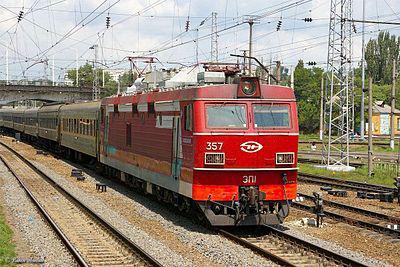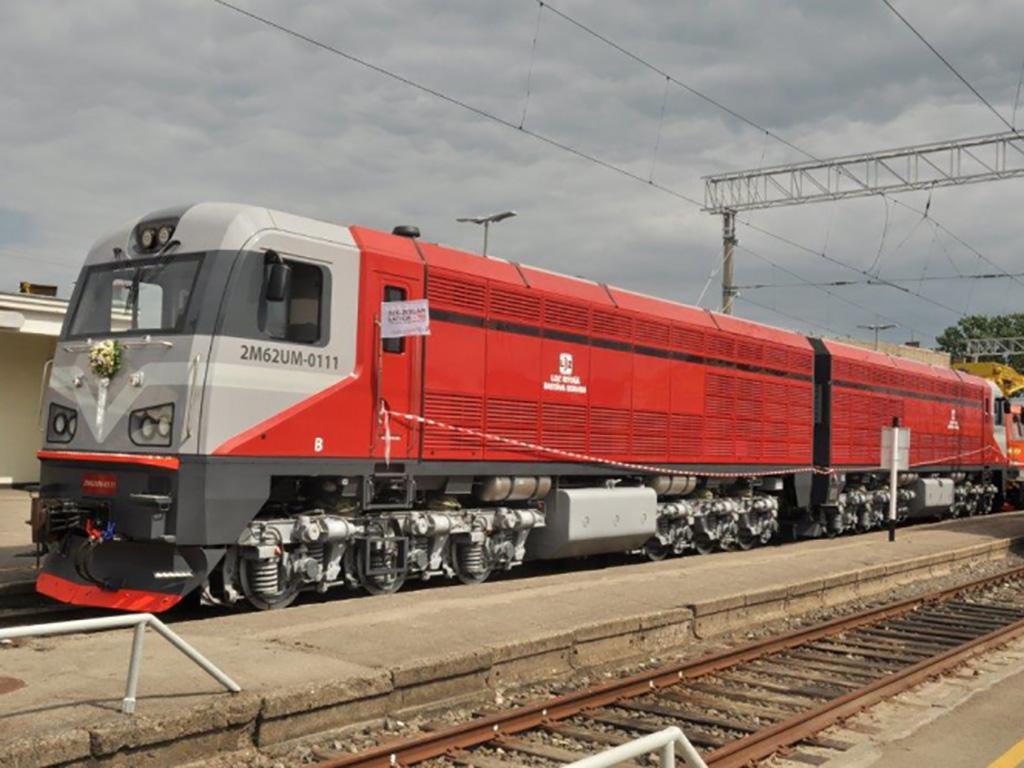The first image is the image on the left, the second image is the image on the right. Analyze the images presented: Is the assertion "All trains are angled forward in the same direction." valid? Answer yes or no. No. The first image is the image on the left, the second image is the image on the right. Evaluate the accuracy of this statement regarding the images: "There are two red trains sitting on train tracks.". Is it true? Answer yes or no. Yes. 